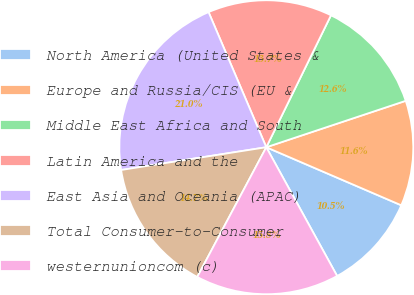Convert chart to OTSL. <chart><loc_0><loc_0><loc_500><loc_500><pie_chart><fcel>North America (United States &<fcel>Europe and Russia/CIS (EU &<fcel>Middle East Africa and South<fcel>Latin America and the<fcel>East Asia and Oceania (APAC)<fcel>Total Consumer-to-Consumer<fcel>westernunioncom (c)<nl><fcel>10.53%<fcel>11.58%<fcel>12.63%<fcel>13.68%<fcel>21.05%<fcel>14.74%<fcel>15.79%<nl></chart> 